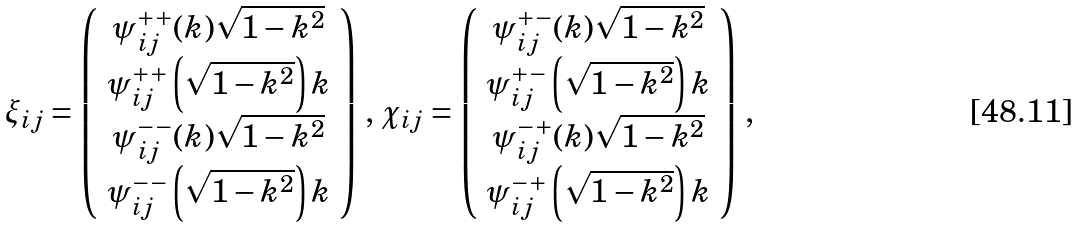<formula> <loc_0><loc_0><loc_500><loc_500>\xi _ { i j } = \left ( \begin{array} { c } \psi ^ { + + } _ { i j } ( k ) \sqrt { 1 - k ^ { 2 } } \\ \psi ^ { + + } _ { i j } \left ( \sqrt { 1 - k ^ { 2 } } \right ) k \\ \psi ^ { - - } _ { i j } ( k ) \sqrt { 1 - k ^ { 2 } } \\ \psi ^ { - - } _ { i j } \left ( \sqrt { 1 - k ^ { 2 } } \right ) k \end{array} \right ) \, , \, \chi _ { i j } = \left ( \begin{array} { c } \psi ^ { + - } _ { i j } ( k ) \sqrt { 1 - k ^ { 2 } } \\ \psi ^ { + - } _ { i j } \left ( \sqrt { 1 - k ^ { 2 } } \right ) k \\ \psi ^ { - + } _ { i j } ( k ) \sqrt { 1 - k ^ { 2 } } \\ \psi ^ { - + } _ { i j } \left ( \sqrt { 1 - k ^ { 2 } } \right ) k \end{array} \right ) \, ,</formula> 